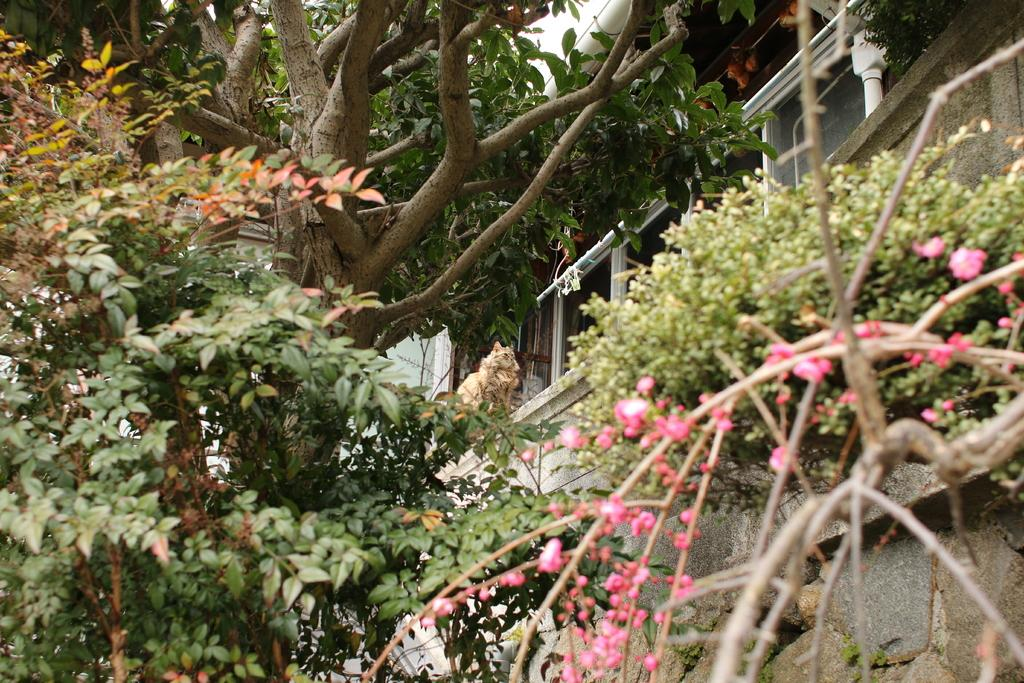What type of tree is on the right side of the image? There is a tree with pink flowers on the right side of the image. What can be seen in the background of the image? There are plants, trees, and a building in the background of the image. Where is the cave located in the image? There is no cave present in the image. What does the tree with pink flowers feel about the building in the background? The tree with pink flowers is an inanimate object and does not have feelings or emotions like shame. 